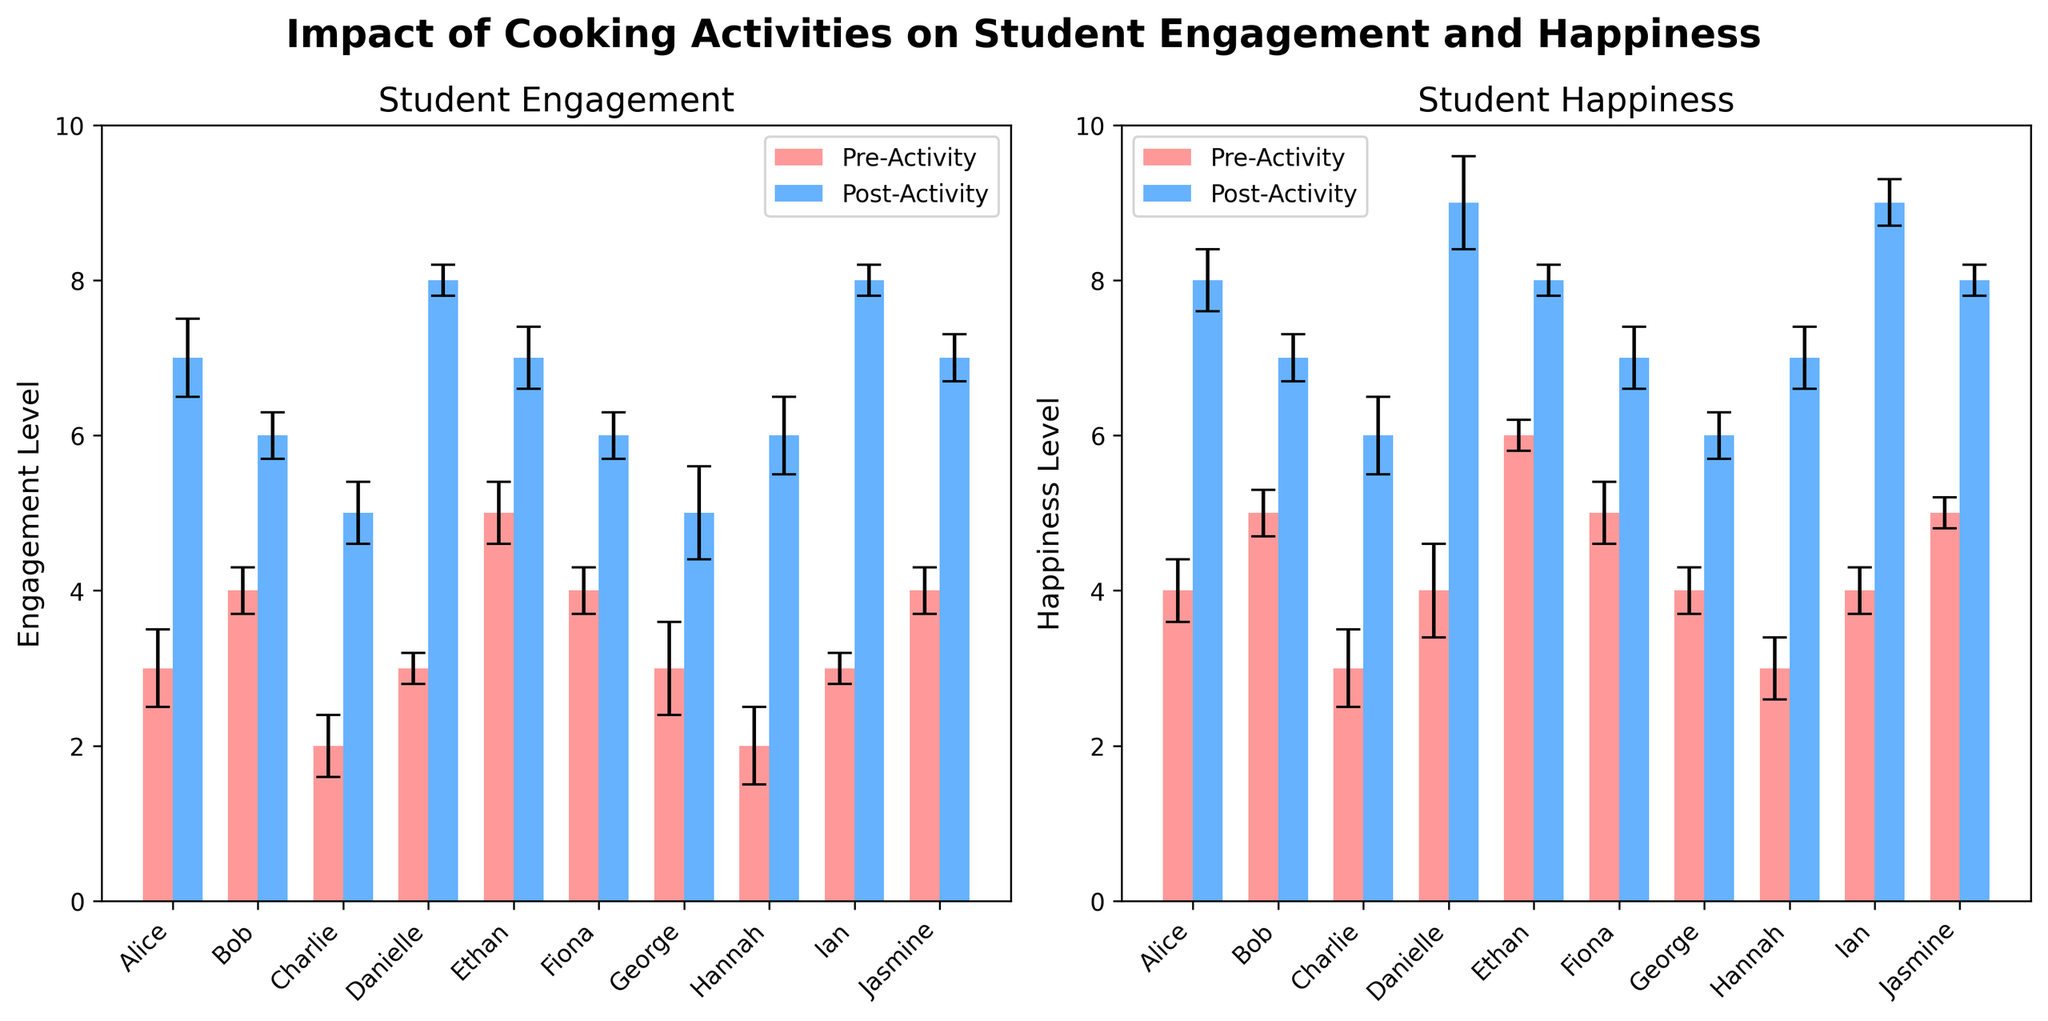Which activity level (engagement or happiness) showed a more significant improvement overall after the cooking activities? By comparing the bars for pre-activity and post-activity in both subplots, we can observe the overall height increase. Engagement levels mostly show a significant increase, with the majority of students having a difference of 2-5 points, while happiness levels also show improvement but with generally smaller increments, often just 1-3 points.
Answer: Engagement Which student had the highest post-activity engagement level? By looking at the heights of the blue bars in the engagement subplot, Ian and Danielle both have the highest post-activity engagement levels at a value of 8.
Answer: Ian and Danielle How many students had a pre-activity happiness level of 4? By looking at the heights of the red bars in the happiness subplot, students Alice, George, and Ian have a pre-activity happiness level of 4.
Answer: 3 What is the difference in post-activity happiness levels between the happiest and least happy students? The highest post-activity happiness level is 9 (Danielle and Ian), and the lowest post-activity happiness level is 6 (George and Charlie). Subtracting these values gives a difference of 3.
Answer: 3 Who had the least improvement in engagement levels after the cooking activity? To find this, look for the smallest difference between the pre-activity (red bar) and post-activity (blue bar) engagement levels. Ethan had an improvement of only 2 points (from 5 to 7).
Answer: Ethan What is the average post-activity engagement level? Sum the post-activity engagement values: 7 (Alice) + 6 (Bob) + 5 (Charlie) + 8 (Danielle) + 7 (Ethan) + 6 (Fiona) + 5 (George) + 6 (Hannah) + 8 (Ian) + 7 (Jasmine) = 65. There are 10 students, so the average is 65/10.
Answer: 6.5 How did Hannah's happiness change after the cooking activity? By comparing the red and blue bars for Hannah in the happiness subplot, her happiness level increased from 3 to 7.
Answer: Increased by 4 Which student experienced the biggest increase in engagement level after the cooking activity? By comparing the differences between pre- and post-activity engagement levels across all students, Danielle and Ian both had the biggest increase of 5 points, from 3 to 8.
Answer: Danielle and Ian 